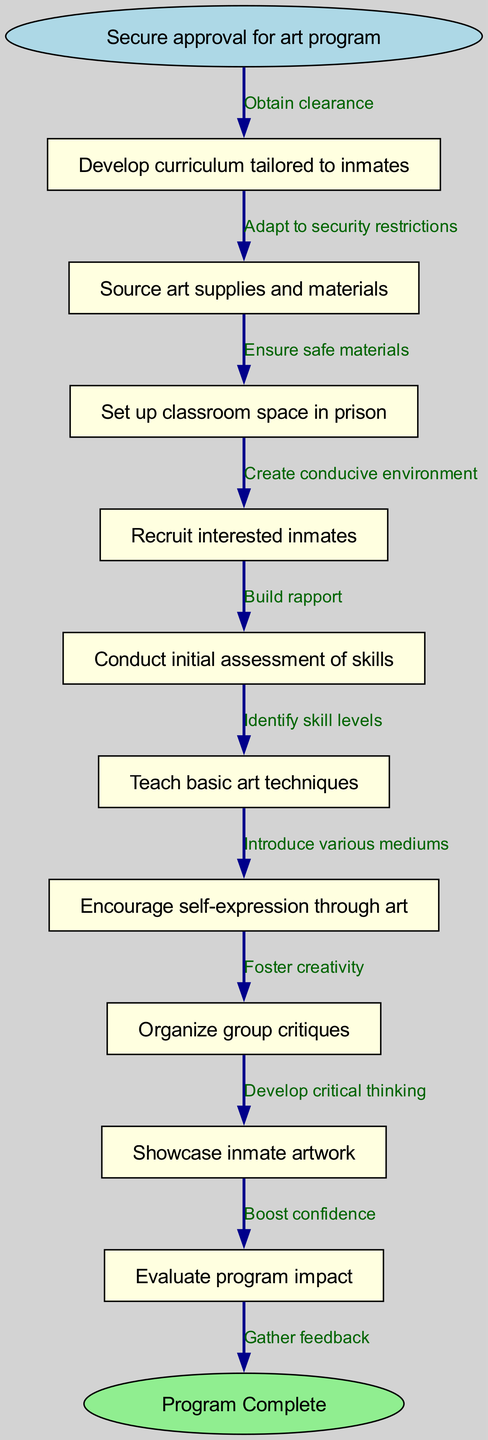What is the starting node of the diagram? The starting node is clearly labeled as "Secure approval for art program," which denotes the initiation point of the process in the flowchart.
Answer: Secure approval for art program How many nodes are in the diagram? By counting each individual entry under "nodes" in the diagram data, it shows a total of 10 distinct nodes are present.
Answer: 10 What is the final step in the process? The end node is specifically labeled as "Program Complete," indicating that this action concludes the entire program flow depicted in the diagram.
Answer: Program Complete What follows after "Conduct initial assessment of skills"? The edge from "Conduct initial assessment of skills" leads directly to "Teach basic art techniques," showing the progression from assessment to actual teaching.
Answer: Teach basic art techniques What is the relationship between "Encourage self-expression through art" and "Organize group critiques"? There is a direct edge that connects "Encourage self-expression through art" to "Organize group critiques," indicating that these two steps are sequentially linked in the flowchart.
Answer: Organize group critiques How many edges are depicted in the diagram? By examining the edges connecting the nodes, there are a total of 11 edges which indicate the directional paths from one node to another throughout the flowchart.
Answer: 11 What must be ensured before sourcing art supplies and materials? The diagram specifies that one must "Adapt to security restrictions" which is a necessary step before any sourcing of materials takes place in the process.
Answer: Adapt to security restrictions Which node is connected to the "Showcase inmate artwork"? The node that directly precedes "Showcase inmate artwork" is "Organize group critiques," establishing that this critique process is a prerequisite for showcasing the artworks.
Answer: Organize group critiques What benefit is associated with "Evaluate program impact"? The connection shows that "Gather feedback" is the final step linked with "Evaluate program impact," indicating that feedback is gathered to assess the overall effectiveness of the art program.
Answer: Gather feedback 